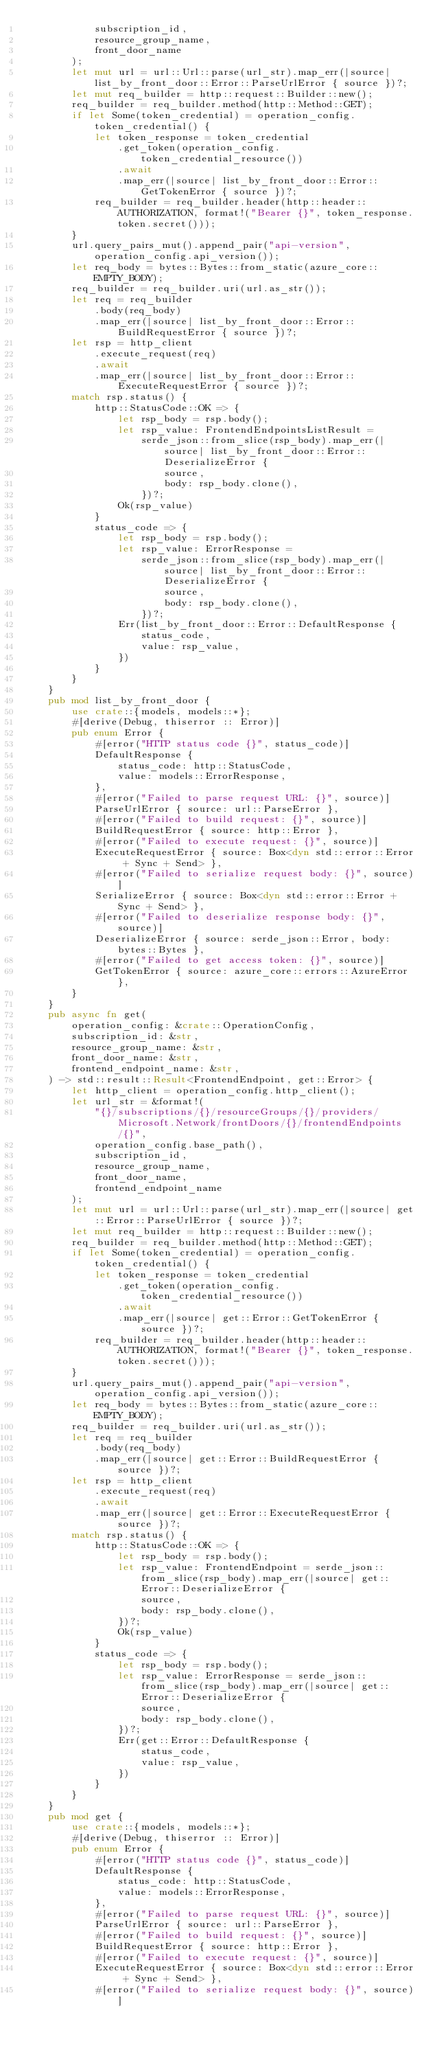<code> <loc_0><loc_0><loc_500><loc_500><_Rust_>            subscription_id,
            resource_group_name,
            front_door_name
        );
        let mut url = url::Url::parse(url_str).map_err(|source| list_by_front_door::Error::ParseUrlError { source })?;
        let mut req_builder = http::request::Builder::new();
        req_builder = req_builder.method(http::Method::GET);
        if let Some(token_credential) = operation_config.token_credential() {
            let token_response = token_credential
                .get_token(operation_config.token_credential_resource())
                .await
                .map_err(|source| list_by_front_door::Error::GetTokenError { source })?;
            req_builder = req_builder.header(http::header::AUTHORIZATION, format!("Bearer {}", token_response.token.secret()));
        }
        url.query_pairs_mut().append_pair("api-version", operation_config.api_version());
        let req_body = bytes::Bytes::from_static(azure_core::EMPTY_BODY);
        req_builder = req_builder.uri(url.as_str());
        let req = req_builder
            .body(req_body)
            .map_err(|source| list_by_front_door::Error::BuildRequestError { source })?;
        let rsp = http_client
            .execute_request(req)
            .await
            .map_err(|source| list_by_front_door::Error::ExecuteRequestError { source })?;
        match rsp.status() {
            http::StatusCode::OK => {
                let rsp_body = rsp.body();
                let rsp_value: FrontendEndpointsListResult =
                    serde_json::from_slice(rsp_body).map_err(|source| list_by_front_door::Error::DeserializeError {
                        source,
                        body: rsp_body.clone(),
                    })?;
                Ok(rsp_value)
            }
            status_code => {
                let rsp_body = rsp.body();
                let rsp_value: ErrorResponse =
                    serde_json::from_slice(rsp_body).map_err(|source| list_by_front_door::Error::DeserializeError {
                        source,
                        body: rsp_body.clone(),
                    })?;
                Err(list_by_front_door::Error::DefaultResponse {
                    status_code,
                    value: rsp_value,
                })
            }
        }
    }
    pub mod list_by_front_door {
        use crate::{models, models::*};
        #[derive(Debug, thiserror :: Error)]
        pub enum Error {
            #[error("HTTP status code {}", status_code)]
            DefaultResponse {
                status_code: http::StatusCode,
                value: models::ErrorResponse,
            },
            #[error("Failed to parse request URL: {}", source)]
            ParseUrlError { source: url::ParseError },
            #[error("Failed to build request: {}", source)]
            BuildRequestError { source: http::Error },
            #[error("Failed to execute request: {}", source)]
            ExecuteRequestError { source: Box<dyn std::error::Error + Sync + Send> },
            #[error("Failed to serialize request body: {}", source)]
            SerializeError { source: Box<dyn std::error::Error + Sync + Send> },
            #[error("Failed to deserialize response body: {}", source)]
            DeserializeError { source: serde_json::Error, body: bytes::Bytes },
            #[error("Failed to get access token: {}", source)]
            GetTokenError { source: azure_core::errors::AzureError },
        }
    }
    pub async fn get(
        operation_config: &crate::OperationConfig,
        subscription_id: &str,
        resource_group_name: &str,
        front_door_name: &str,
        frontend_endpoint_name: &str,
    ) -> std::result::Result<FrontendEndpoint, get::Error> {
        let http_client = operation_config.http_client();
        let url_str = &format!(
            "{}/subscriptions/{}/resourceGroups/{}/providers/Microsoft.Network/frontDoors/{}/frontendEndpoints/{}",
            operation_config.base_path(),
            subscription_id,
            resource_group_name,
            front_door_name,
            frontend_endpoint_name
        );
        let mut url = url::Url::parse(url_str).map_err(|source| get::Error::ParseUrlError { source })?;
        let mut req_builder = http::request::Builder::new();
        req_builder = req_builder.method(http::Method::GET);
        if let Some(token_credential) = operation_config.token_credential() {
            let token_response = token_credential
                .get_token(operation_config.token_credential_resource())
                .await
                .map_err(|source| get::Error::GetTokenError { source })?;
            req_builder = req_builder.header(http::header::AUTHORIZATION, format!("Bearer {}", token_response.token.secret()));
        }
        url.query_pairs_mut().append_pair("api-version", operation_config.api_version());
        let req_body = bytes::Bytes::from_static(azure_core::EMPTY_BODY);
        req_builder = req_builder.uri(url.as_str());
        let req = req_builder
            .body(req_body)
            .map_err(|source| get::Error::BuildRequestError { source })?;
        let rsp = http_client
            .execute_request(req)
            .await
            .map_err(|source| get::Error::ExecuteRequestError { source })?;
        match rsp.status() {
            http::StatusCode::OK => {
                let rsp_body = rsp.body();
                let rsp_value: FrontendEndpoint = serde_json::from_slice(rsp_body).map_err(|source| get::Error::DeserializeError {
                    source,
                    body: rsp_body.clone(),
                })?;
                Ok(rsp_value)
            }
            status_code => {
                let rsp_body = rsp.body();
                let rsp_value: ErrorResponse = serde_json::from_slice(rsp_body).map_err(|source| get::Error::DeserializeError {
                    source,
                    body: rsp_body.clone(),
                })?;
                Err(get::Error::DefaultResponse {
                    status_code,
                    value: rsp_value,
                })
            }
        }
    }
    pub mod get {
        use crate::{models, models::*};
        #[derive(Debug, thiserror :: Error)]
        pub enum Error {
            #[error("HTTP status code {}", status_code)]
            DefaultResponse {
                status_code: http::StatusCode,
                value: models::ErrorResponse,
            },
            #[error("Failed to parse request URL: {}", source)]
            ParseUrlError { source: url::ParseError },
            #[error("Failed to build request: {}", source)]
            BuildRequestError { source: http::Error },
            #[error("Failed to execute request: {}", source)]
            ExecuteRequestError { source: Box<dyn std::error::Error + Sync + Send> },
            #[error("Failed to serialize request body: {}", source)]</code> 